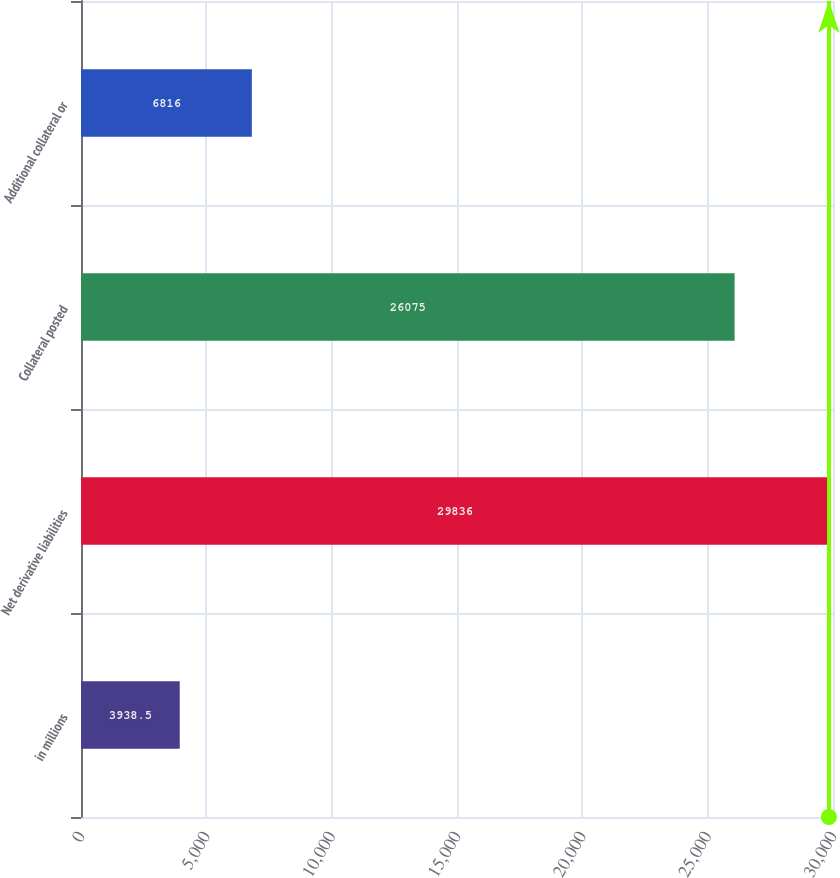Convert chart. <chart><loc_0><loc_0><loc_500><loc_500><bar_chart><fcel>in millions<fcel>Net derivative liabilities<fcel>Collateral posted<fcel>Additional collateral or<nl><fcel>3938.5<fcel>29836<fcel>26075<fcel>6816<nl></chart> 